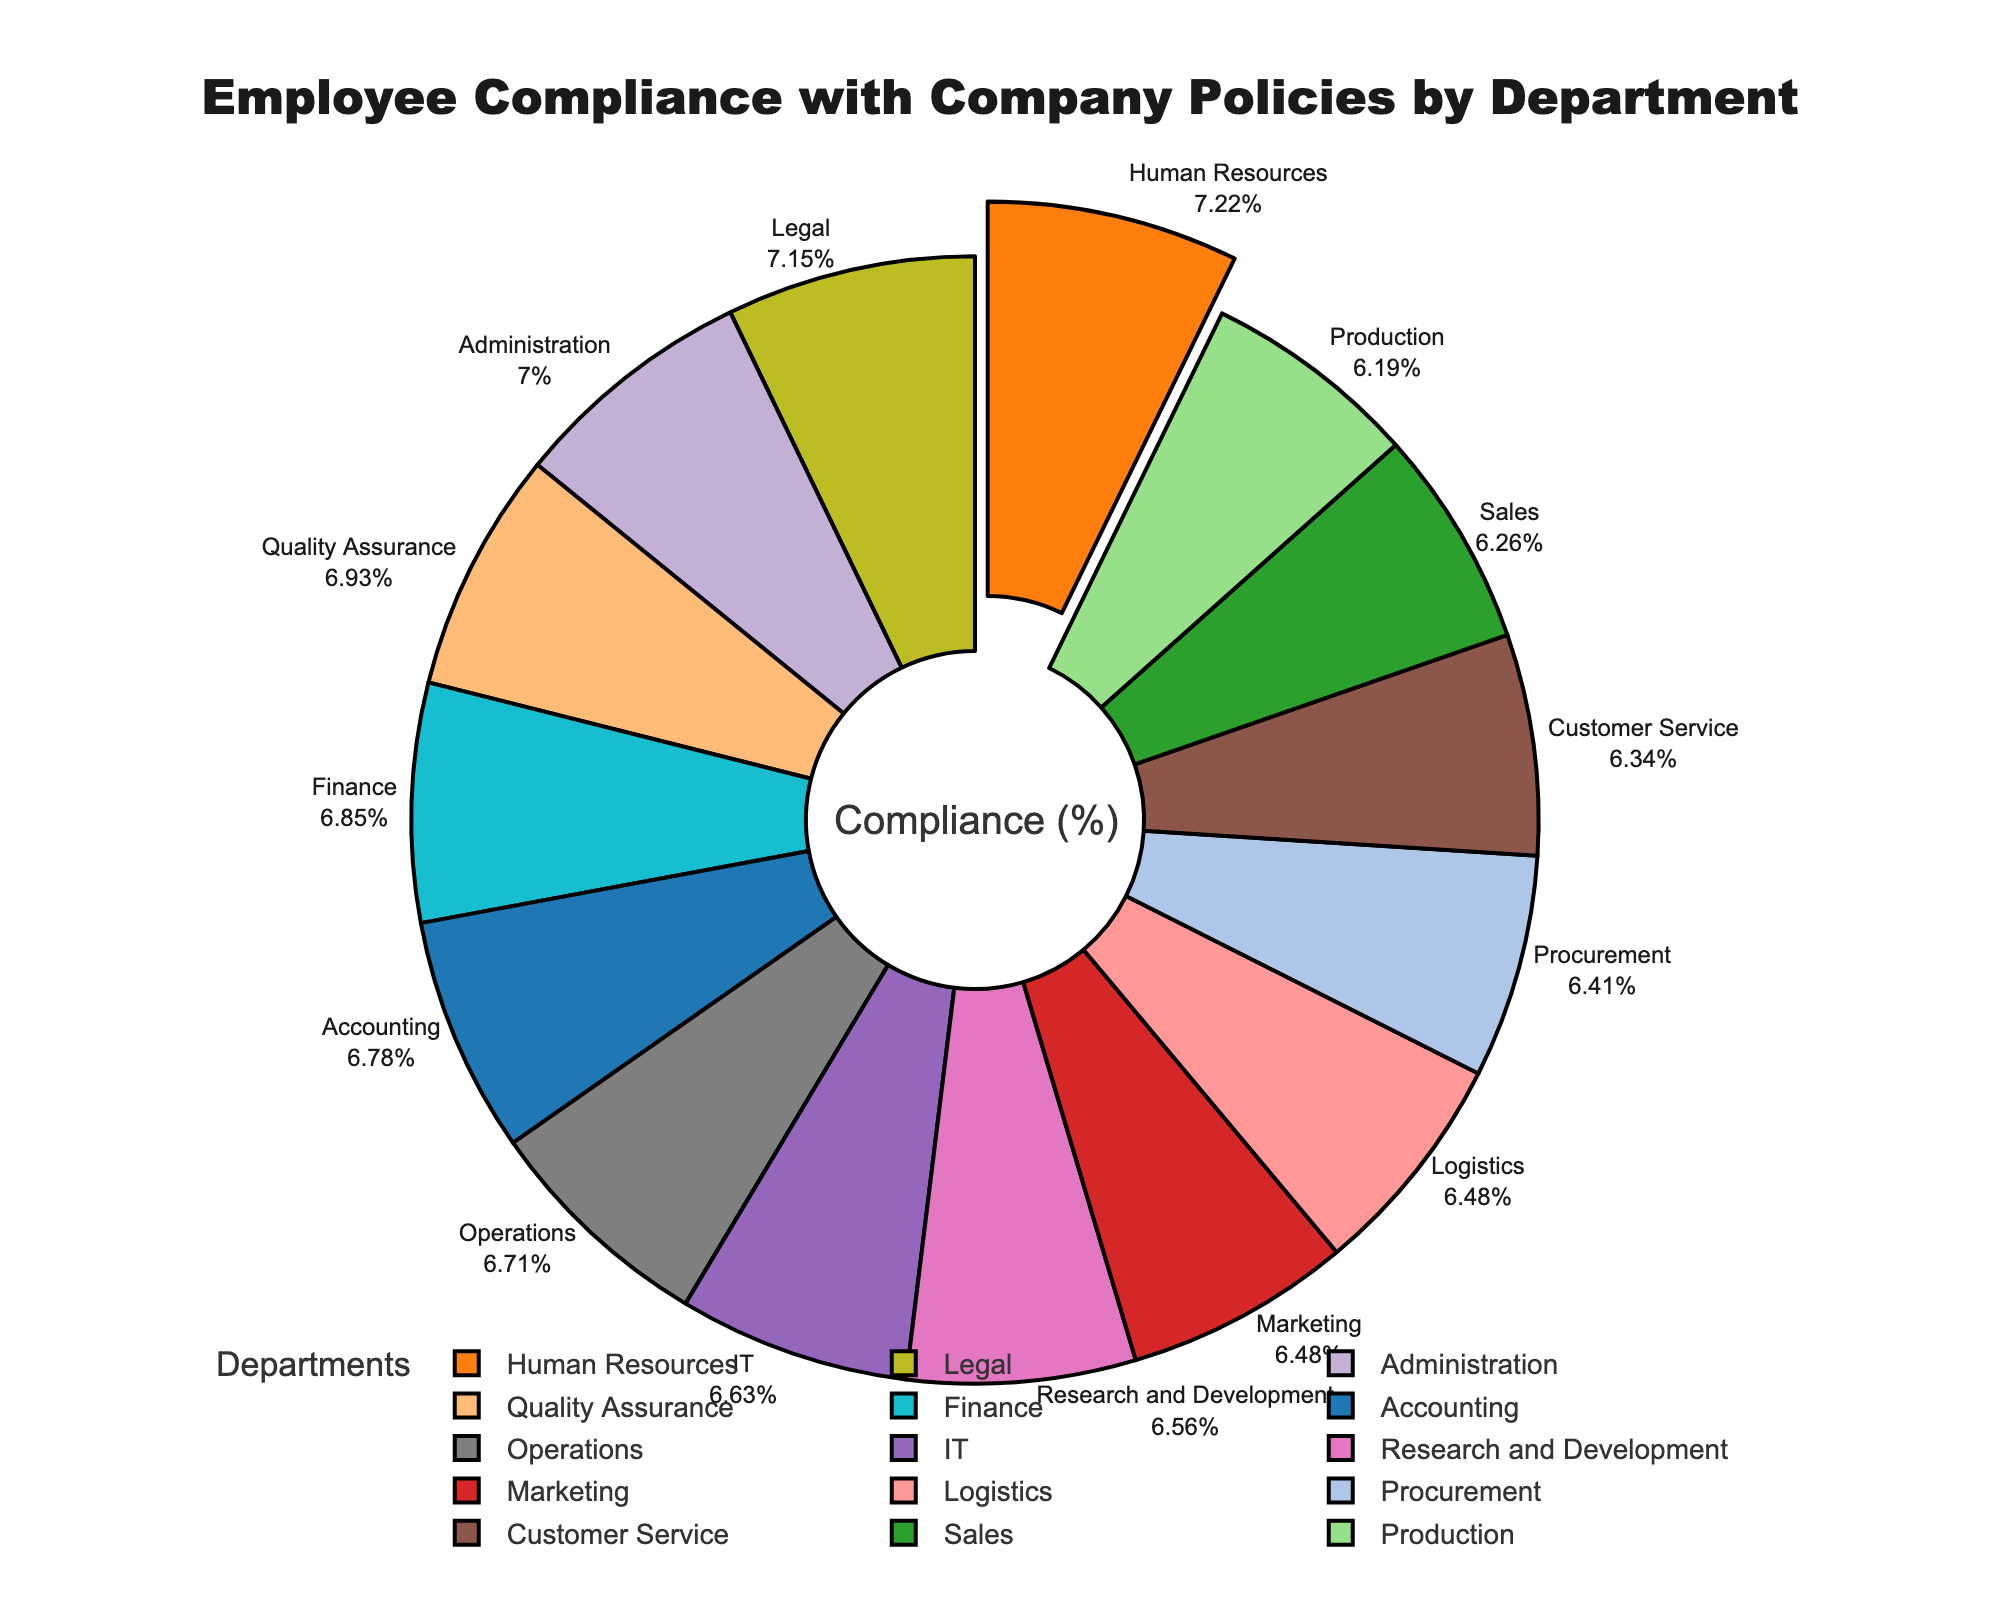Which department has the highest compliance percentage? The figure highlights the department with the highest compliance percentage by pulling its segment outward. Referring to the figure, it's the Human Resources department.
Answer: Human Resources Which department has the lowest compliance percentage? The department with the smallest slice in the pie chart indicates the lowest compliance percentage. From the figure, it's the Production department.
Answer: Production How much higher is the compliance percentage of the Legal department compared to the Sales department? Legal has a compliance percentage of 97%, and Sales has 85%. Subtract these percentages to find the difference: 97% - 85% = 12%.
Answer: 12% What is the average compliance percentage across all departments? Sum all the compliance percentages (92 + 98 + 85 + 88 + 90 + 86 + 89 + 91 + 97 + 93 + 87 + 94 + 84 + 88 + 95) = 1257. There are 15 departments, so divide the total by 15. 1257 / 15 = 83.8.
Answer: 83.8 Which departments have a compliance percentage above 90%? The departments with slices larger than others, labeled with percentages over 90%, are: Accounting, Human Resources, IT, Legal, Finance, Quality Assurance, and Administration.
Answer: Accounting, Human Resources, IT, Legal, Finance, Quality Assurance, Administration What is the sum of compliance percentages for Customer Service and Marketing? Customer Service has 86%, and Marketing has 88%. Add these percentages together to get the sum: 86% + 88% = 174%.
Answer: 174% Which department's compliance percentage is closest to the average compliance percentage? First, calculate the average compliance percentage (83.8%). Now, observe the data to find the closest value: IT and Operations both have compliance percentages of 90%, which is close to 83.8%.
Answer: IT and Operations Compare the compliance percentages between the Research and Development and Procurement departments. Which one has higher compliance? Look at the slices for Research and Development (89%) and Procurement (87%). The Research and Development department's slice is larger, indicating a higher compliance percentage.
Answer: Research and Development What is the difference in compliance percentage between the Accounting and Operations departments? Accounting has a compliance percentage of 92%, and Operations has 91%. Subtract these percentages: 92% - 91% = 1%.
Answer: 1% What are the three departments with the smallest compliance percentages, and what are their values? Identify the three smallest slices in the pie chart. Production (84%), Sales (85%), and Customer Service (86%) have the smallest compliance percentages.
Answer: Production (84%), Sales (85%), Customer Service (86%) 